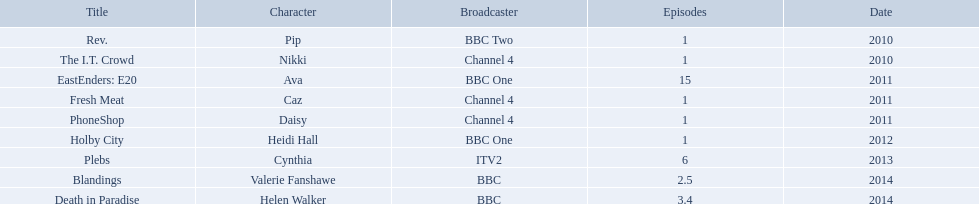How many episodes did sophie colquhoun star in on rev.? 1. What character did she play on phoneshop? Daisy. What role did she play on itv2? Cynthia. Which characters were featured in more then one episode? Ava, Cynthia, Valerie Fanshawe, Helen Walker. Which of these were not in 2014? Ava, Cynthia. Which one of those was not on a bbc broadcaster? Cynthia. Could you parse the entire table? {'header': ['Title', 'Character', 'Broadcaster', 'Episodes', 'Date'], 'rows': [['Rev.', 'Pip', 'BBC Two', '1', '2010'], ['The I.T. Crowd', 'Nikki', 'Channel 4', '1', '2010'], ['EastEnders: E20', 'Ava', 'BBC One', '15', '2011'], ['Fresh Meat', 'Caz', 'Channel 4', '1', '2011'], ['PhoneShop', 'Daisy', 'Channel 4', '1', '2011'], ['Holby City', 'Heidi Hall', 'BBC One', '1', '2012'], ['Plebs', 'Cynthia', 'ITV2', '6', '2013'], ['Blandings', 'Valerie Fanshawe', 'BBC', '2.5', '2014'], ['Death in Paradise', 'Helen Walker', 'BBC', '3.4', '2014']]} How many episodes of rev. starred sophie colquhoun? 1. What persona did she take on in phoneshop? Daisy. What position did she hold on itv2? Cynthia. In the show rev., how many episodes featured sophie colquhoun? 1. Which character did she portray in phoneshop? Daisy. What part did she perform on itv2? Cynthia. What is the number of episodes in rev. that starred sophie colquhoun? 1. In phoneshop, which character was she? Daisy. On itv2, what was her role? Cynthia. Which characters appeared in multiple episodes? Ava, Cynthia, Valerie Fanshawe, Helen Walker. Among them, who were not present in 2014? Ava, Cynthia. And which one wasn't broadcasted on a bbc network? Cynthia. What were the characters she portrayed? Pip, Nikki, Ava, Caz, Daisy, Heidi Hall, Cynthia, Valerie Fanshawe, Helen Walker. Which networks featured her? BBC Two, Channel 4, BBC One, Channel 4, Channel 4, BBC One, ITV2, BBC, BBC. Which roles did she perform specifically for itv2? Cynthia. Which parts did she act in? Pip, Nikki, Ava, Caz, Daisy, Heidi Hall, Cynthia, Valerie Fanshawe, Helen Walker. On which broadcasting platforms? BBC Two, Channel 4, BBC One, Channel 4, Channel 4, BBC One, ITV2, BBC, BBC. What were her roles on itv2? Cynthia. 